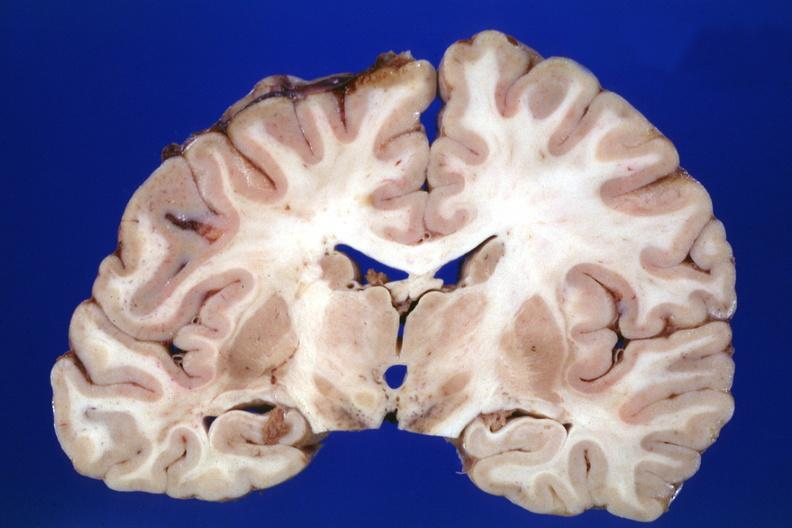does infarcts show no lesion the lesion was in the pons?
Answer the question using a single word or phrase. No 